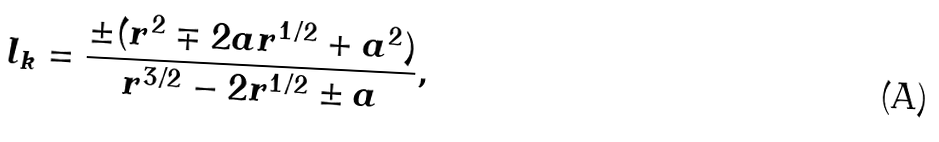<formula> <loc_0><loc_0><loc_500><loc_500>l _ { k } = \frac { \pm ( r ^ { 2 } \mp 2 a r ^ { 1 / 2 } + a ^ { 2 } ) } { r ^ { 3 / 2 } - 2 r ^ { 1 / 2 } \pm a } ,</formula> 